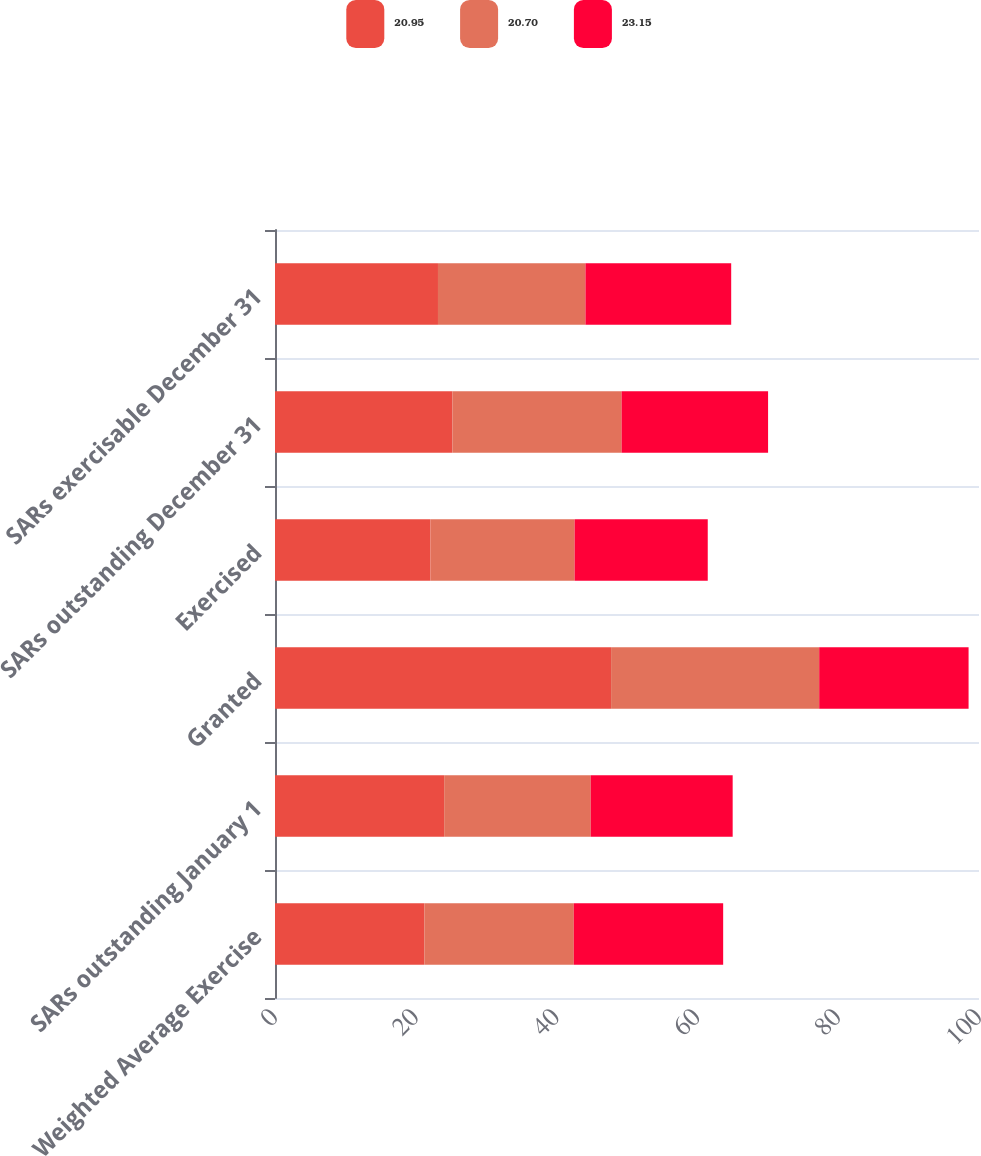Convert chart. <chart><loc_0><loc_0><loc_500><loc_500><stacked_bar_chart><ecel><fcel>Weighted Average Exercise<fcel>SARs outstanding January 1<fcel>Granted<fcel>Exercised<fcel>SARs outstanding December 31<fcel>SARs exercisable December 31<nl><fcel>20.95<fcel>21.22<fcel>24.03<fcel>47.74<fcel>22.09<fcel>25.2<fcel>23.15<nl><fcel>20.7<fcel>21.22<fcel>20.81<fcel>29.56<fcel>20.47<fcel>24.03<fcel>20.95<nl><fcel>23.15<fcel>21.22<fcel>20.17<fcel>21.22<fcel>18.91<fcel>20.81<fcel>20.7<nl></chart> 